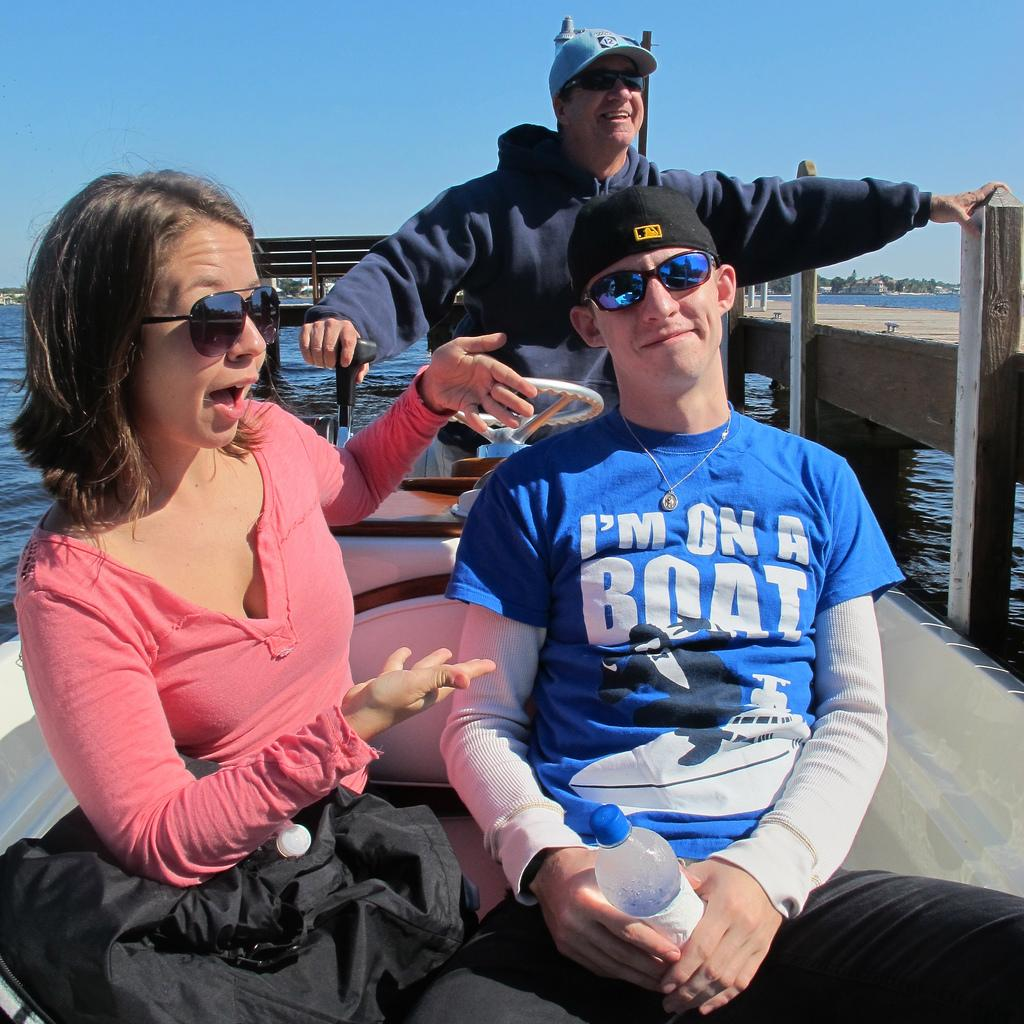<image>
Offer a succinct explanation of the picture presented. A man wearing a shirt that says "I'm On A Boat" is riding in a boat with a woman and a man. 